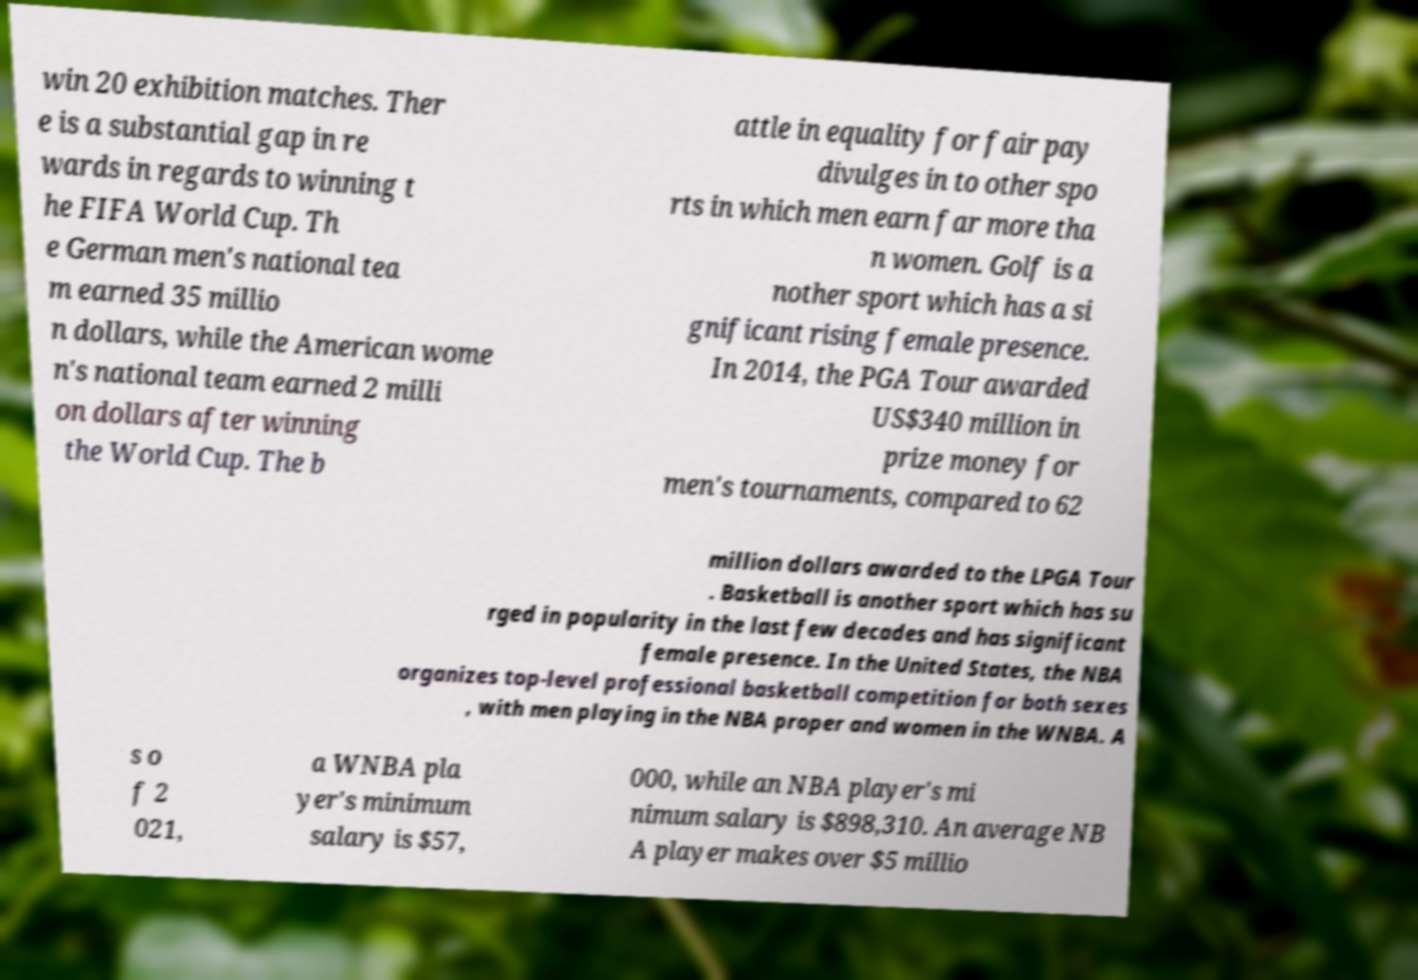What messages or text are displayed in this image? I need them in a readable, typed format. win 20 exhibition matches. Ther e is a substantial gap in re wards in regards to winning t he FIFA World Cup. Th e German men's national tea m earned 35 millio n dollars, while the American wome n's national team earned 2 milli on dollars after winning the World Cup. The b attle in equality for fair pay divulges in to other spo rts in which men earn far more tha n women. Golf is a nother sport which has a si gnificant rising female presence. In 2014, the PGA Tour awarded US$340 million in prize money for men's tournaments, compared to 62 million dollars awarded to the LPGA Tour . Basketball is another sport which has su rged in popularity in the last few decades and has significant female presence. In the United States, the NBA organizes top-level professional basketball competition for both sexes , with men playing in the NBA proper and women in the WNBA. A s o f 2 021, a WNBA pla yer's minimum salary is $57, 000, while an NBA player's mi nimum salary is $898,310. An average NB A player makes over $5 millio 